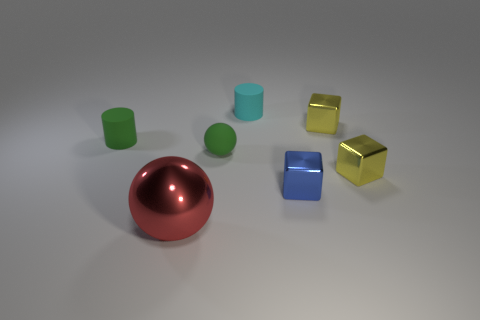Subtract 1 blocks. How many blocks are left? 2 Add 3 brown shiny cylinders. How many objects exist? 10 Subtract all balls. How many objects are left? 5 Add 6 big red shiny balls. How many big red shiny balls exist? 7 Subtract 0 blue spheres. How many objects are left? 7 Subtract all big red shiny cylinders. Subtract all red things. How many objects are left? 6 Add 2 small green matte spheres. How many small green matte spheres are left? 3 